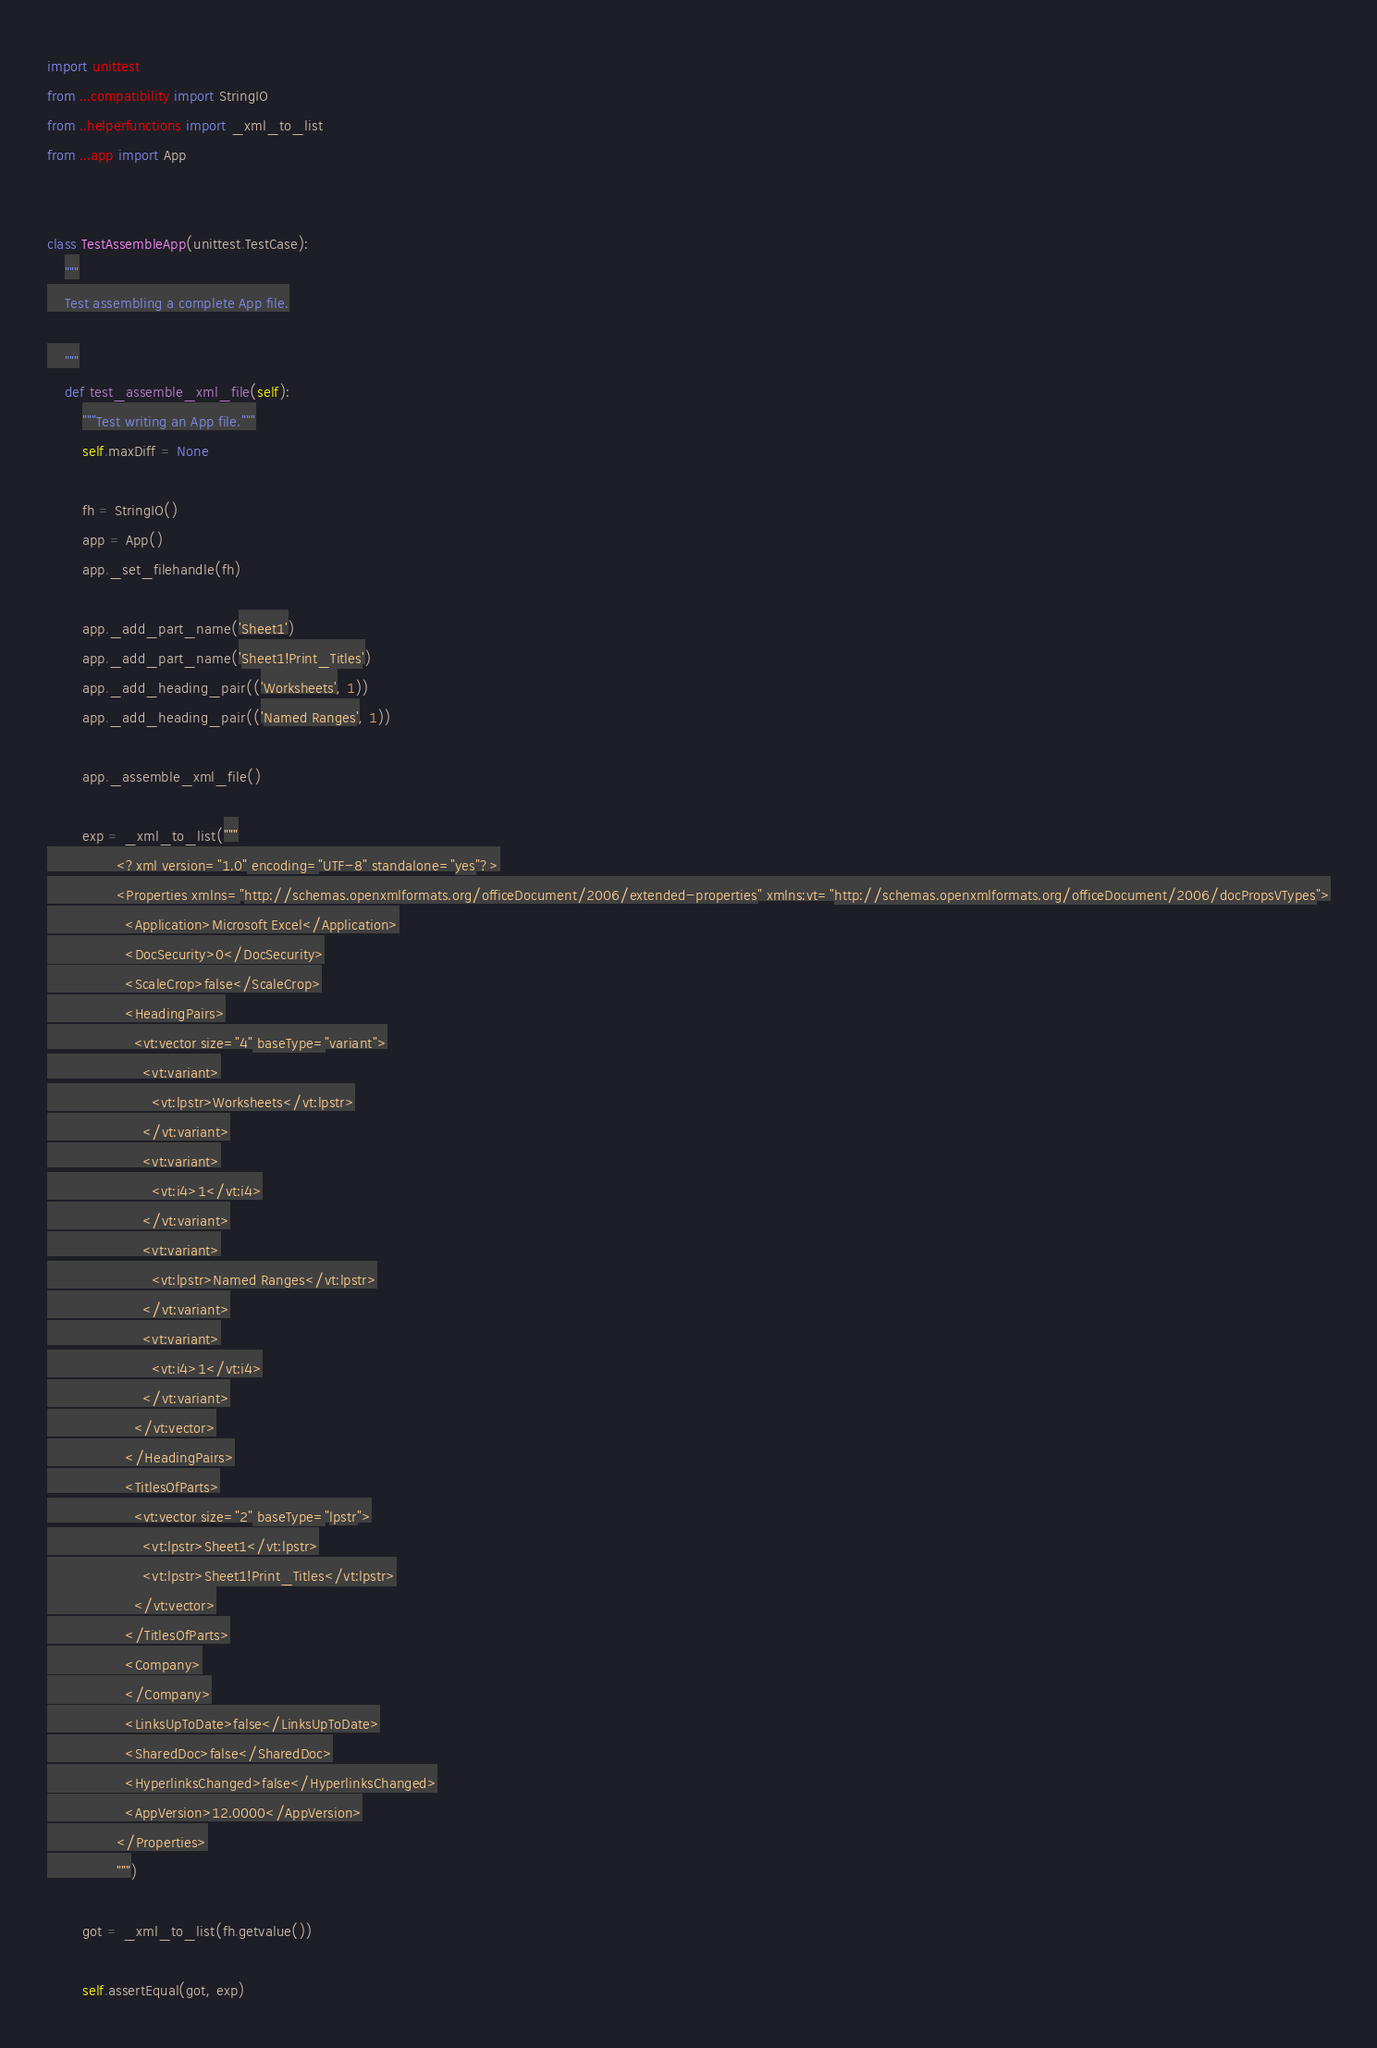<code> <loc_0><loc_0><loc_500><loc_500><_Python_>import unittest
from ...compatibility import StringIO
from ..helperfunctions import _xml_to_list
from ...app import App


class TestAssembleApp(unittest.TestCase):
    """
    Test assembling a complete App file.

    """
    def test_assemble_xml_file(self):
        """Test writing an App file."""
        self.maxDiff = None

        fh = StringIO()
        app = App()
        app._set_filehandle(fh)

        app._add_part_name('Sheet1')
        app._add_part_name('Sheet1!Print_Titles')
        app._add_heading_pair(('Worksheets', 1))
        app._add_heading_pair(('Named Ranges', 1))

        app._assemble_xml_file()

        exp = _xml_to_list("""
                <?xml version="1.0" encoding="UTF-8" standalone="yes"?>
                <Properties xmlns="http://schemas.openxmlformats.org/officeDocument/2006/extended-properties" xmlns:vt="http://schemas.openxmlformats.org/officeDocument/2006/docPropsVTypes">
                  <Application>Microsoft Excel</Application>
                  <DocSecurity>0</DocSecurity>
                  <ScaleCrop>false</ScaleCrop>
                  <HeadingPairs>
                    <vt:vector size="4" baseType="variant">
                      <vt:variant>
                        <vt:lpstr>Worksheets</vt:lpstr>
                      </vt:variant>
                      <vt:variant>
                        <vt:i4>1</vt:i4>
                      </vt:variant>
                      <vt:variant>
                        <vt:lpstr>Named Ranges</vt:lpstr>
                      </vt:variant>
                      <vt:variant>
                        <vt:i4>1</vt:i4>
                      </vt:variant>
                    </vt:vector>
                  </HeadingPairs>
                  <TitlesOfParts>
                    <vt:vector size="2" baseType="lpstr">
                      <vt:lpstr>Sheet1</vt:lpstr>
                      <vt:lpstr>Sheet1!Print_Titles</vt:lpstr>
                    </vt:vector>
                  </TitlesOfParts>
                  <Company>
                  </Company>
                  <LinksUpToDate>false</LinksUpToDate>
                  <SharedDoc>false</SharedDoc>
                  <HyperlinksChanged>false</HyperlinksChanged>
                  <AppVersion>12.0000</AppVersion>
                </Properties>
                """)

        got = _xml_to_list(fh.getvalue())

        self.assertEqual(got, exp)
</code> 